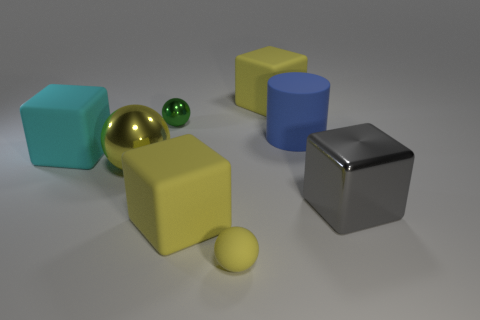Subtract all blue blocks. Subtract all gray cylinders. How many blocks are left? 4 Add 1 big blue matte things. How many objects exist? 9 Subtract all cylinders. How many objects are left? 7 Subtract all small green metallic spheres. Subtract all gray blocks. How many objects are left? 6 Add 6 small metallic objects. How many small metallic objects are left? 7 Add 8 large yellow spheres. How many large yellow spheres exist? 9 Subtract 0 red balls. How many objects are left? 8 